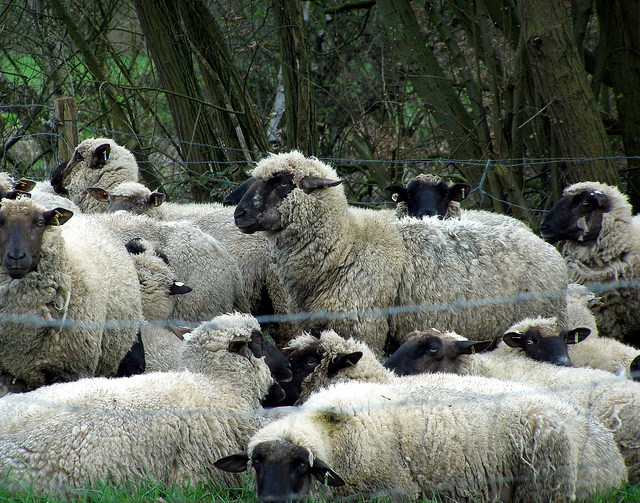Do any of the sheep appear to be doing something different or unique? Most of the sheep in the image appear to be standing or resting close to each other. While there isn't any sheep performing a distinctly unique action, they all seem to display a sense of attentiveness, possibly due to being observed or photographed. 